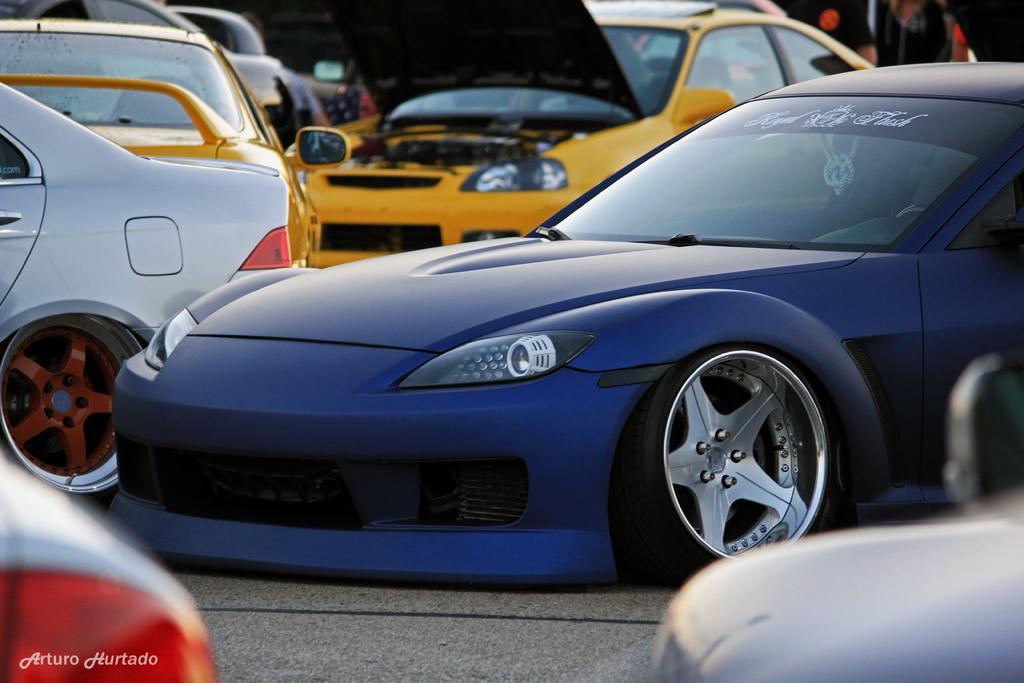Please provide a concise description of this image. In this picture we can see a group of vehicles on the ground. 